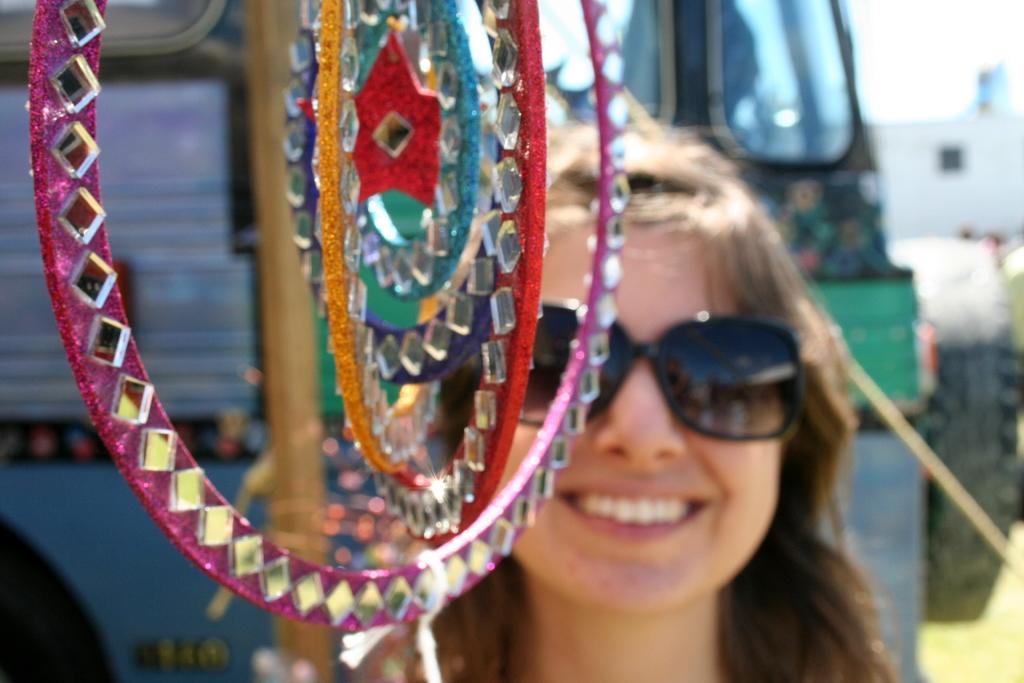Who is present in the image? There is a woman in the image. What is the woman's facial expression? The woman is smiling. What is located in front of the woman? There is an object in front of the woman. What can be seen behind the woman? There is a bus behind the woman. Are there any cobwebs visible on the woman's clothing in the image? There is no mention of cobwebs in the provided facts, and therefore we cannot determine their presence in the image. 